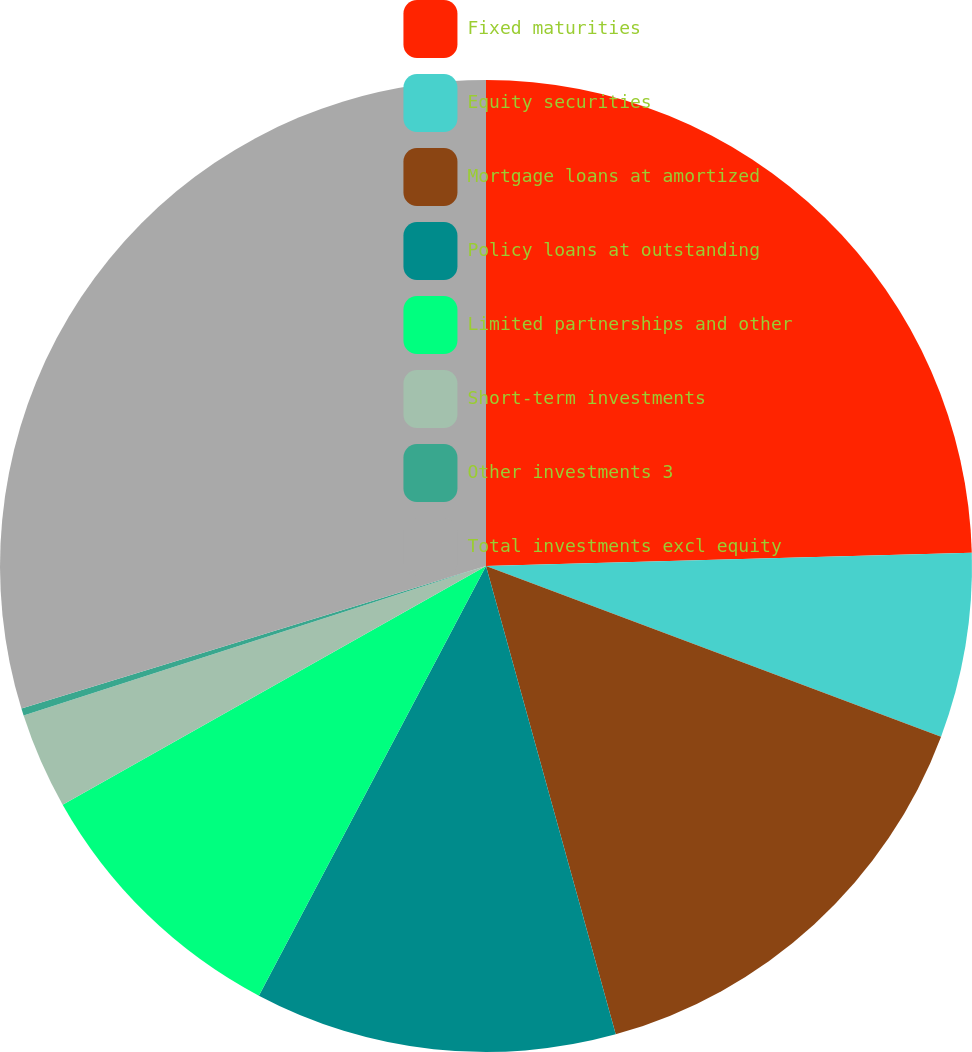Convert chart. <chart><loc_0><loc_0><loc_500><loc_500><pie_chart><fcel>Fixed maturities<fcel>Equity securities<fcel>Mortgage loans at amortized<fcel>Policy loans at outstanding<fcel>Limited partnerships and other<fcel>Short-term investments<fcel>Other investments 3<fcel>Total investments excl equity<nl><fcel>24.57%<fcel>6.14%<fcel>14.99%<fcel>12.04%<fcel>9.09%<fcel>3.19%<fcel>0.24%<fcel>29.74%<nl></chart> 